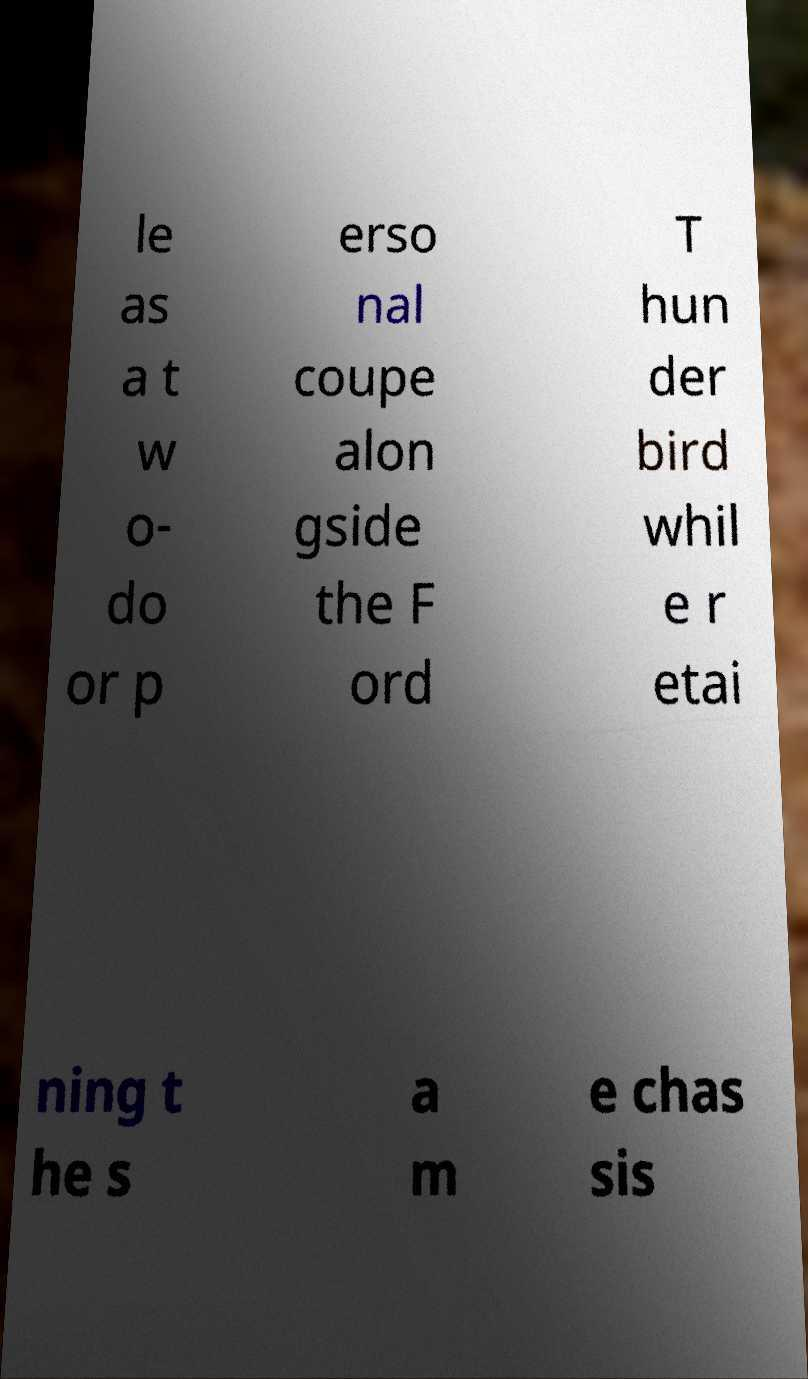Can you read and provide the text displayed in the image?This photo seems to have some interesting text. Can you extract and type it out for me? le as a t w o- do or p erso nal coupe alon gside the F ord T hun der bird whil e r etai ning t he s a m e chas sis 